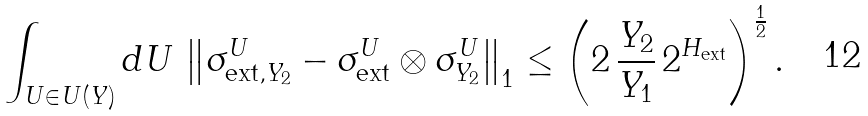Convert formula to latex. <formula><loc_0><loc_0><loc_500><loc_500>\int _ { U \in U ( Y ) } d U \, \left \| \sigma _ { \text {ext} , Y _ { 2 } } ^ { U } - \sigma _ { \text {ext} } ^ { U } \otimes \sigma _ { Y _ { 2 } } ^ { U } \right \| _ { 1 } \leq \left ( 2 \, \frac { Y _ { 2 } } { Y _ { 1 } } \, 2 ^ { H _ { \text {ext} } } \right ) ^ { \frac { 1 } { 2 } } .</formula> 